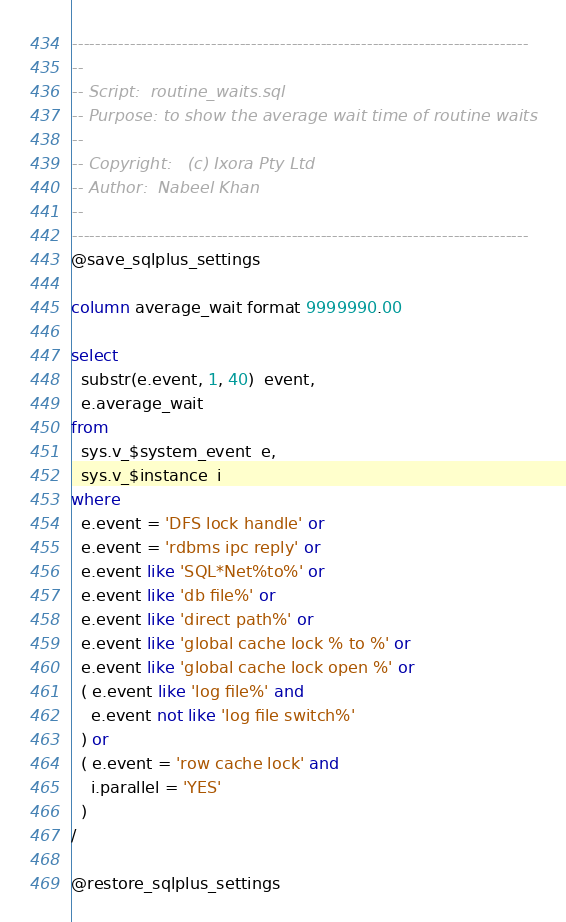<code> <loc_0><loc_0><loc_500><loc_500><_SQL_>-------------------------------------------------------------------------------
--
-- Script:	routine_waits.sql
-- Purpose:	to show the average wait time of routine waits
--
-- Copyright:	(c) Ixora Pty Ltd
-- Author:	Nabeel Khan
--
-------------------------------------------------------------------------------
@save_sqlplus_settings

column average_wait format 9999990.00

select
  substr(e.event, 1, 40)  event,
  e.average_wait
from
  sys.v_$system_event  e,
  sys.v_$instance  i
where
  e.event = 'DFS lock handle' or
  e.event = 'rdbms ipc reply' or
  e.event like 'SQL*Net%to%' or
  e.event like 'db file%' or
  e.event like 'direct path%' or
  e.event like 'global cache lock % to %' or
  e.event like 'global cache lock open %' or
  ( e.event like 'log file%' and
    e.event not like 'log file switch%'
  ) or
  ( e.event = 'row cache lock' and
    i.parallel = 'YES'
  )
/

@restore_sqlplus_settings
</code> 